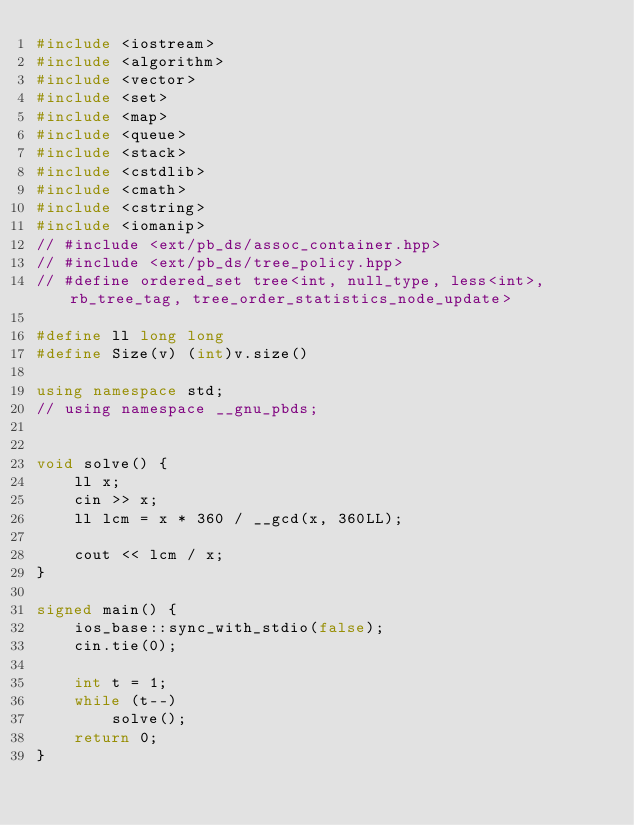<code> <loc_0><loc_0><loc_500><loc_500><_C++_>#include <iostream>
#include <algorithm>
#include <vector>
#include <set>
#include <map>
#include <queue>
#include <stack>
#include <cstdlib>
#include <cmath>
#include <cstring>
#include <iomanip>
// #include <ext/pb_ds/assoc_container.hpp>
// #include <ext/pb_ds/tree_policy.hpp>
// #define ordered_set tree<int, null_type, less<int>, rb_tree_tag, tree_order_statistics_node_update>

#define ll long long
#define Size(v) (int)v.size()

using namespace std;
// using namespace __gnu_pbds;


void solve() {
	ll x;
	cin >> x;
	ll lcm = x * 360 / __gcd(x, 360LL);

	cout << lcm / x;
}

signed main() {
	ios_base::sync_with_stdio(false);
	cin.tie(0);

	int t = 1;
	while (t--) 
		solve();
	return 0;
}</code> 